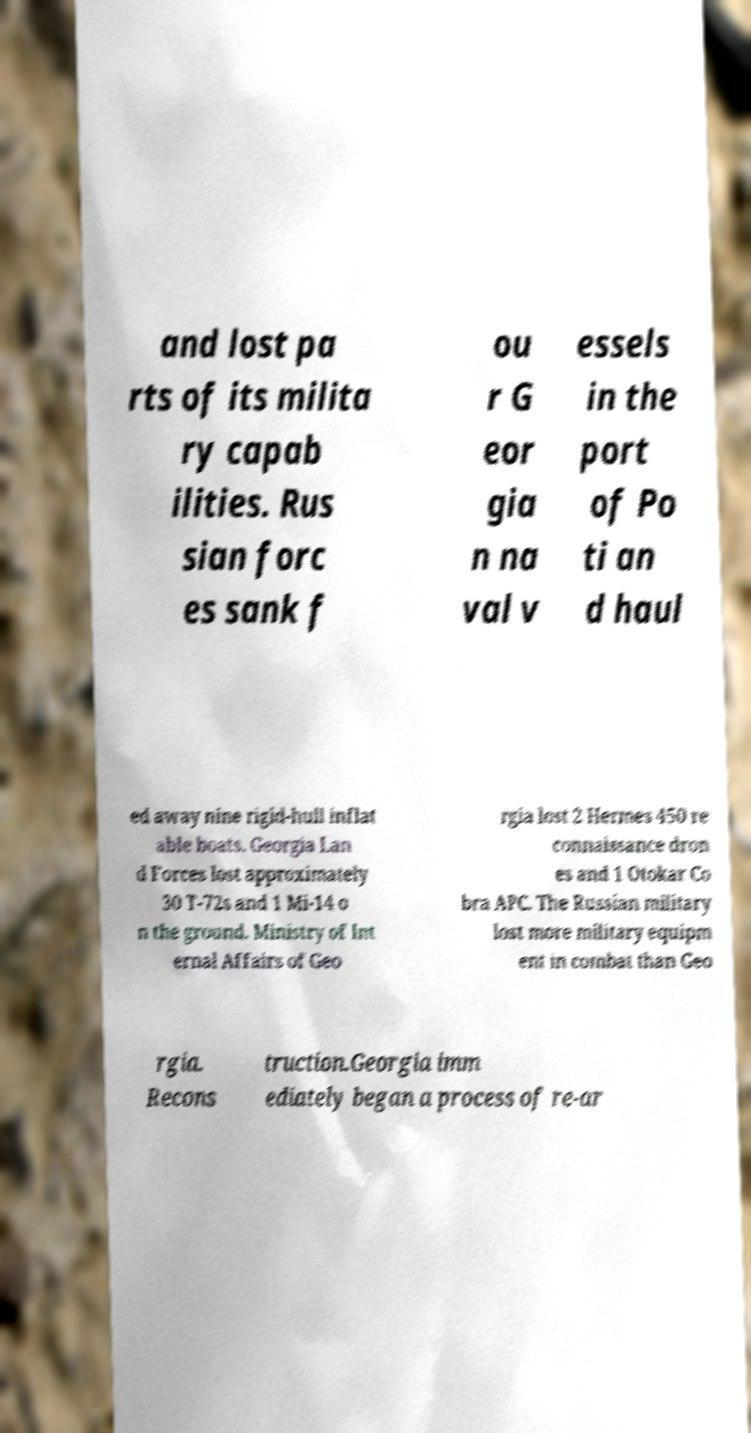Could you extract and type out the text from this image? and lost pa rts of its milita ry capab ilities. Rus sian forc es sank f ou r G eor gia n na val v essels in the port of Po ti an d haul ed away nine rigid-hull inflat able boats. Georgia Lan d Forces lost approximately 30 T-72s and 1 Mi-14 o n the ground. Ministry of Int ernal Affairs of Geo rgia lost 2 Hermes 450 re connaissance dron es and 1 Otokar Co bra APC. The Russian military lost more military equipm ent in combat than Geo rgia. Recons truction.Georgia imm ediately began a process of re-ar 